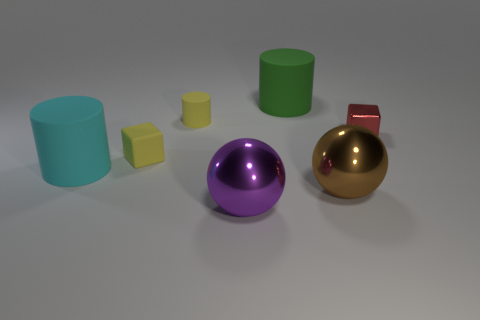How many other things are there of the same color as the tiny metallic cube?
Offer a very short reply. 0. What number of things are cubes that are left of the shiny cube or tiny yellow objects in front of the metallic block?
Provide a short and direct response. 1. There is a shiny object that is behind the small block that is in front of the small red metallic cube; how big is it?
Provide a short and direct response. Small. What is the size of the metal block?
Provide a short and direct response. Small. Is the color of the small block that is on the left side of the brown thing the same as the small rubber thing behind the small red metal object?
Give a very brief answer. Yes. How many other objects are the same material as the large green thing?
Make the answer very short. 3. Are there any big blue blocks?
Offer a very short reply. No. Is the large object to the left of the tiny yellow rubber cube made of the same material as the green cylinder?
Keep it short and to the point. Yes. What is the material of the other thing that is the same shape as the big purple metallic thing?
Make the answer very short. Metal. Is the number of tiny yellow rubber cylinders less than the number of tiny cyan rubber cubes?
Give a very brief answer. No. 